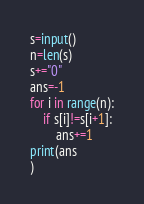<code> <loc_0><loc_0><loc_500><loc_500><_Python_>s=input()
n=len(s)
s+="0"
ans=-1
for i in range(n):
    if s[i]!=s[i+1]:
        ans+=1
print(ans
)</code> 